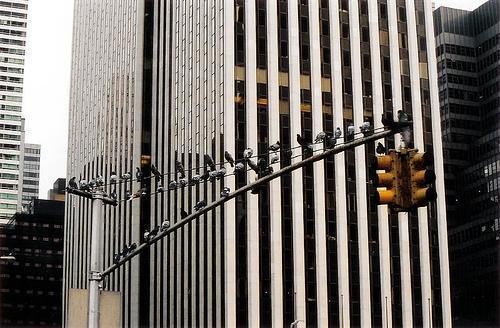What are the birds perched on?
From the following four choices, select the correct answer to address the question.
Options: Bench, traffic light, branch, window. Traffic light. 